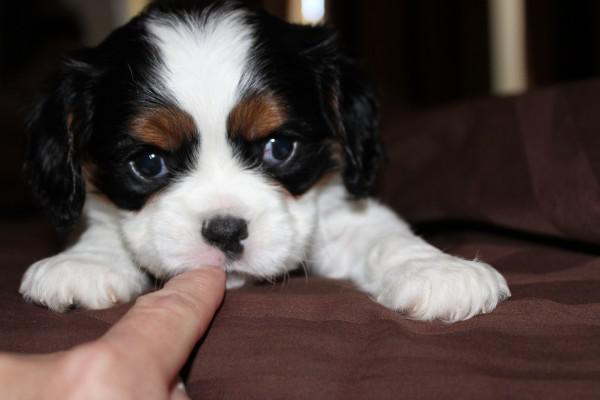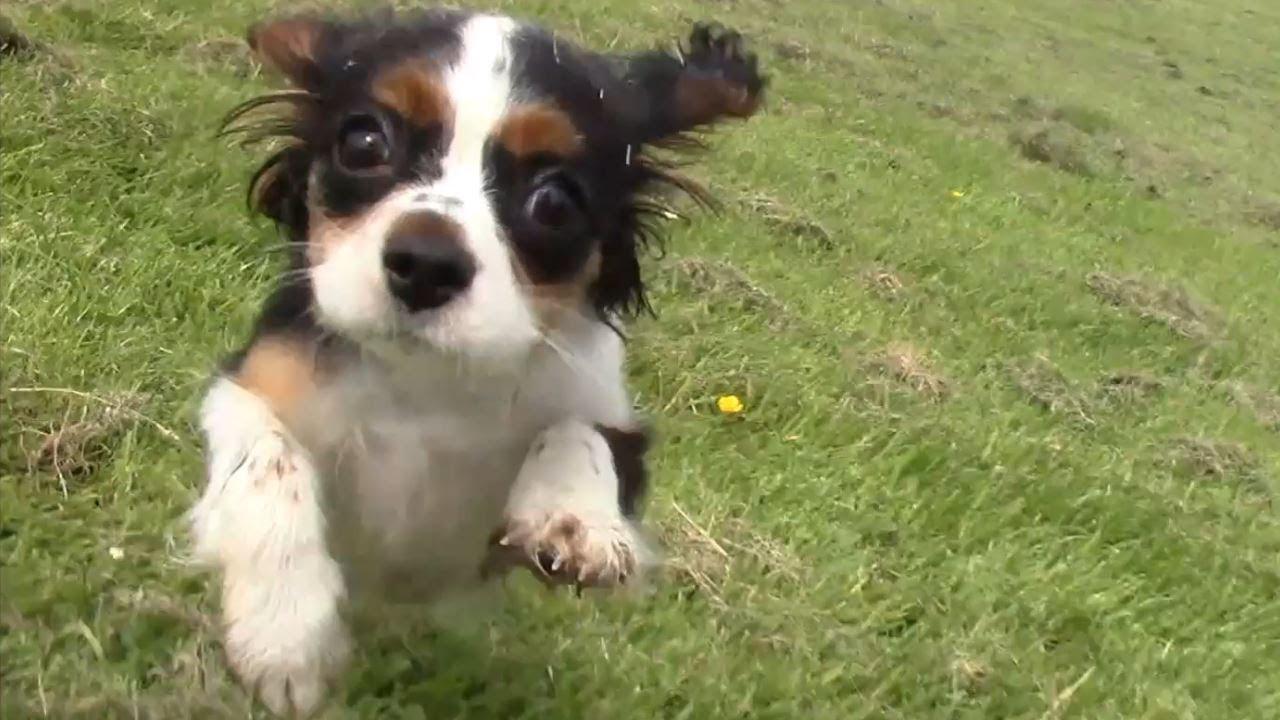The first image is the image on the left, the second image is the image on the right. Given the left and right images, does the statement "At least one image shows one or more Cavalier King Charles Spaniels sitting upright." hold true? Answer yes or no. No. The first image is the image on the left, the second image is the image on the right. For the images shown, is this caption "The image on the left contains twp dogs sitting next to each other." true? Answer yes or no. No. 